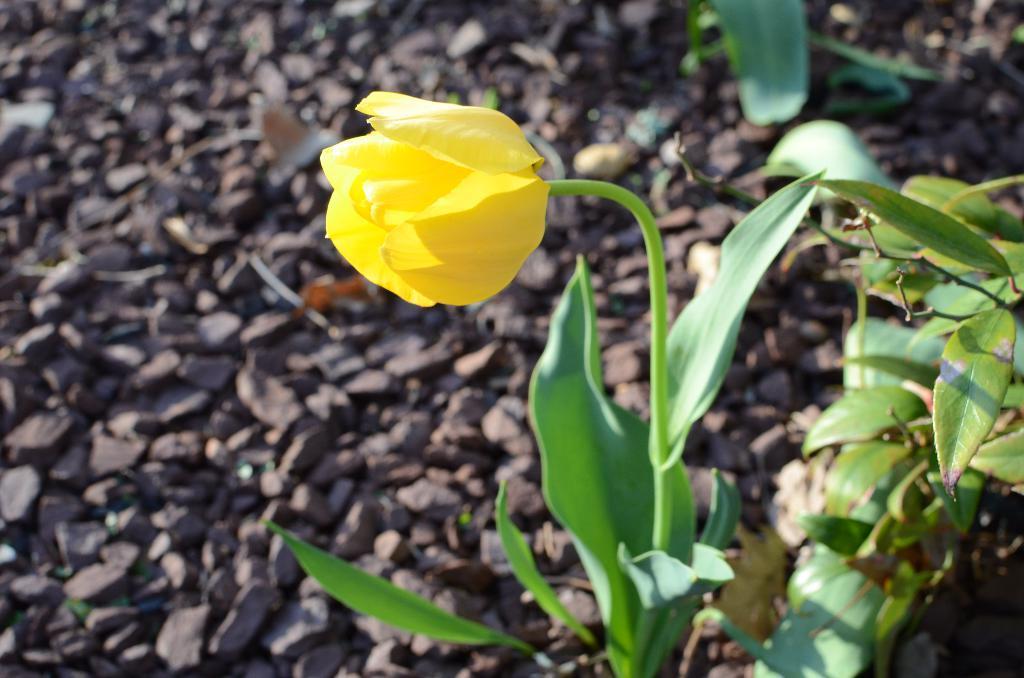In one or two sentences, can you explain what this image depicts? In this picture we can see a yellow flower on a plant. There are a few green leaves on the right side. We can see some stones on the path. 